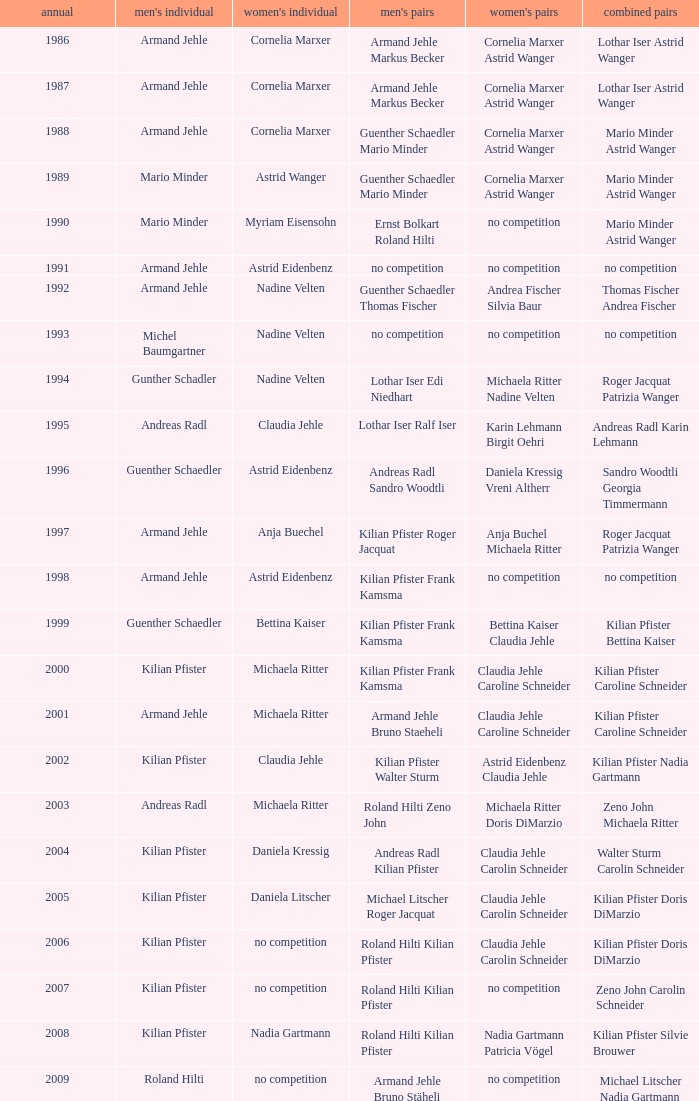In 2004, where the womens singles is daniela kressig who is the mens singles Kilian Pfister. 